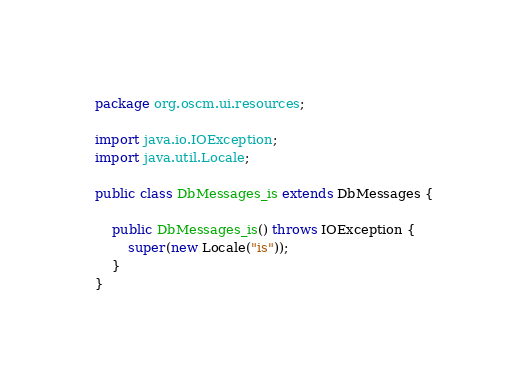Convert code to text. <code><loc_0><loc_0><loc_500><loc_500><_Java_>
package org.oscm.ui.resources;

import java.io.IOException;
import java.util.Locale;

public class DbMessages_is extends DbMessages {

    public DbMessages_is() throws IOException {
        super(new Locale("is"));
    }
}
</code> 